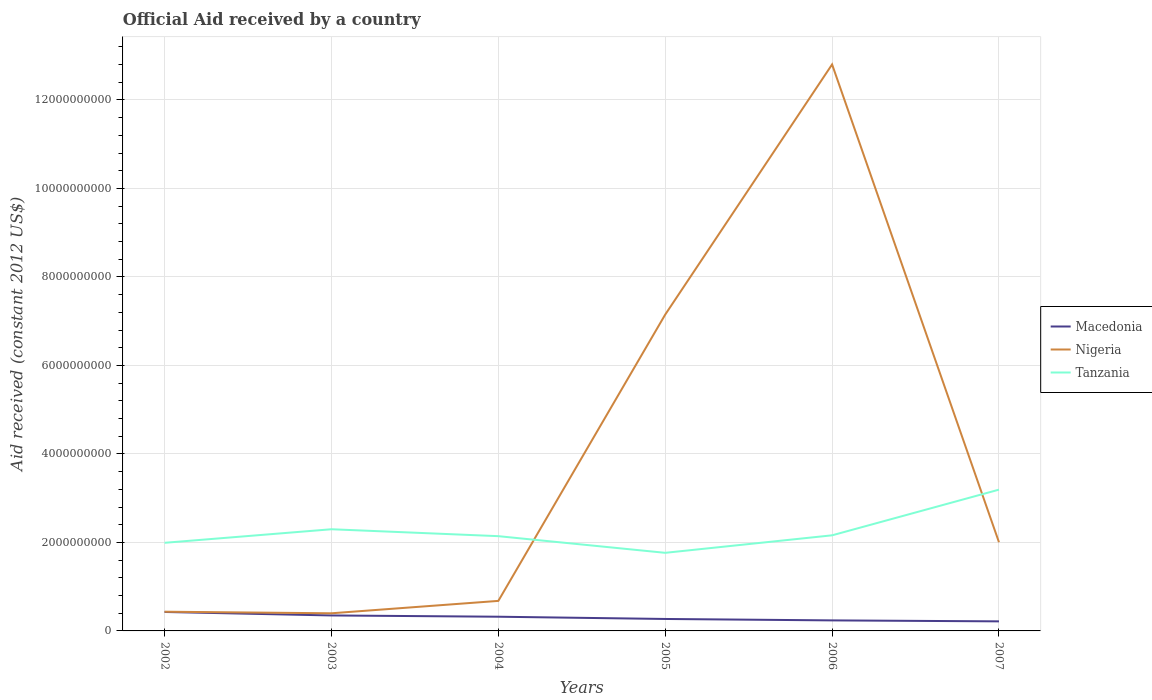How many different coloured lines are there?
Give a very brief answer. 3. Does the line corresponding to Nigeria intersect with the line corresponding to Tanzania?
Ensure brevity in your answer.  Yes. Is the number of lines equal to the number of legend labels?
Give a very brief answer. Yes. Across all years, what is the maximum net official aid received in Macedonia?
Your answer should be very brief. 2.16e+08. What is the total net official aid received in Tanzania in the graph?
Offer a terse response. 3.77e+08. What is the difference between the highest and the second highest net official aid received in Tanzania?
Keep it short and to the point. 1.43e+09. What is the difference between the highest and the lowest net official aid received in Nigeria?
Provide a short and direct response. 2. What is the title of the graph?
Keep it short and to the point. Official Aid received by a country. Does "Latin America(all income levels)" appear as one of the legend labels in the graph?
Keep it short and to the point. No. What is the label or title of the X-axis?
Your answer should be very brief. Years. What is the label or title of the Y-axis?
Give a very brief answer. Aid received (constant 2012 US$). What is the Aid received (constant 2012 US$) in Macedonia in 2002?
Your answer should be compact. 4.28e+08. What is the Aid received (constant 2012 US$) of Nigeria in 2002?
Your response must be concise. 4.34e+08. What is the Aid received (constant 2012 US$) in Tanzania in 2002?
Your answer should be very brief. 1.99e+09. What is the Aid received (constant 2012 US$) in Macedonia in 2003?
Offer a very short reply. 3.50e+08. What is the Aid received (constant 2012 US$) in Nigeria in 2003?
Your answer should be compact. 3.99e+08. What is the Aid received (constant 2012 US$) of Tanzania in 2003?
Give a very brief answer. 2.30e+09. What is the Aid received (constant 2012 US$) in Macedonia in 2004?
Your response must be concise. 3.21e+08. What is the Aid received (constant 2012 US$) of Nigeria in 2004?
Keep it short and to the point. 6.79e+08. What is the Aid received (constant 2012 US$) in Tanzania in 2004?
Give a very brief answer. 2.14e+09. What is the Aid received (constant 2012 US$) of Macedonia in 2005?
Your response must be concise. 2.70e+08. What is the Aid received (constant 2012 US$) in Nigeria in 2005?
Your response must be concise. 7.15e+09. What is the Aid received (constant 2012 US$) of Tanzania in 2005?
Offer a terse response. 1.77e+09. What is the Aid received (constant 2012 US$) in Macedonia in 2006?
Make the answer very short. 2.38e+08. What is the Aid received (constant 2012 US$) in Nigeria in 2006?
Your answer should be very brief. 1.28e+1. What is the Aid received (constant 2012 US$) in Tanzania in 2006?
Offer a terse response. 2.16e+09. What is the Aid received (constant 2012 US$) in Macedonia in 2007?
Provide a succinct answer. 2.16e+08. What is the Aid received (constant 2012 US$) of Nigeria in 2007?
Give a very brief answer. 2.00e+09. What is the Aid received (constant 2012 US$) of Tanzania in 2007?
Offer a very short reply. 3.19e+09. Across all years, what is the maximum Aid received (constant 2012 US$) in Macedonia?
Provide a short and direct response. 4.28e+08. Across all years, what is the maximum Aid received (constant 2012 US$) in Nigeria?
Your answer should be very brief. 1.28e+1. Across all years, what is the maximum Aid received (constant 2012 US$) of Tanzania?
Make the answer very short. 3.19e+09. Across all years, what is the minimum Aid received (constant 2012 US$) of Macedonia?
Make the answer very short. 2.16e+08. Across all years, what is the minimum Aid received (constant 2012 US$) in Nigeria?
Your response must be concise. 3.99e+08. Across all years, what is the minimum Aid received (constant 2012 US$) in Tanzania?
Your response must be concise. 1.77e+09. What is the total Aid received (constant 2012 US$) in Macedonia in the graph?
Your answer should be very brief. 1.82e+09. What is the total Aid received (constant 2012 US$) of Nigeria in the graph?
Your response must be concise. 2.35e+1. What is the total Aid received (constant 2012 US$) of Tanzania in the graph?
Offer a very short reply. 1.35e+1. What is the difference between the Aid received (constant 2012 US$) in Macedonia in 2002 and that in 2003?
Offer a very short reply. 7.88e+07. What is the difference between the Aid received (constant 2012 US$) in Nigeria in 2002 and that in 2003?
Make the answer very short. 3.58e+07. What is the difference between the Aid received (constant 2012 US$) of Tanzania in 2002 and that in 2003?
Your response must be concise. -3.06e+08. What is the difference between the Aid received (constant 2012 US$) of Macedonia in 2002 and that in 2004?
Your answer should be compact. 1.07e+08. What is the difference between the Aid received (constant 2012 US$) of Nigeria in 2002 and that in 2004?
Ensure brevity in your answer.  -2.44e+08. What is the difference between the Aid received (constant 2012 US$) of Tanzania in 2002 and that in 2004?
Make the answer very short. -1.50e+08. What is the difference between the Aid received (constant 2012 US$) in Macedonia in 2002 and that in 2005?
Give a very brief answer. 1.58e+08. What is the difference between the Aid received (constant 2012 US$) in Nigeria in 2002 and that in 2005?
Provide a succinct answer. -6.72e+09. What is the difference between the Aid received (constant 2012 US$) of Tanzania in 2002 and that in 2005?
Make the answer very short. 2.26e+08. What is the difference between the Aid received (constant 2012 US$) of Macedonia in 2002 and that in 2006?
Give a very brief answer. 1.90e+08. What is the difference between the Aid received (constant 2012 US$) of Nigeria in 2002 and that in 2006?
Your answer should be very brief. -1.24e+1. What is the difference between the Aid received (constant 2012 US$) in Tanzania in 2002 and that in 2006?
Offer a very short reply. -1.69e+08. What is the difference between the Aid received (constant 2012 US$) of Macedonia in 2002 and that in 2007?
Your answer should be compact. 2.12e+08. What is the difference between the Aid received (constant 2012 US$) in Nigeria in 2002 and that in 2007?
Offer a very short reply. -1.57e+09. What is the difference between the Aid received (constant 2012 US$) of Tanzania in 2002 and that in 2007?
Offer a terse response. -1.20e+09. What is the difference between the Aid received (constant 2012 US$) in Macedonia in 2003 and that in 2004?
Provide a succinct answer. 2.86e+07. What is the difference between the Aid received (constant 2012 US$) in Nigeria in 2003 and that in 2004?
Your response must be concise. -2.80e+08. What is the difference between the Aid received (constant 2012 US$) in Tanzania in 2003 and that in 2004?
Provide a succinct answer. 1.56e+08. What is the difference between the Aid received (constant 2012 US$) in Macedonia in 2003 and that in 2005?
Make the answer very short. 7.94e+07. What is the difference between the Aid received (constant 2012 US$) in Nigeria in 2003 and that in 2005?
Ensure brevity in your answer.  -6.75e+09. What is the difference between the Aid received (constant 2012 US$) of Tanzania in 2003 and that in 2005?
Ensure brevity in your answer.  5.33e+08. What is the difference between the Aid received (constant 2012 US$) of Macedonia in 2003 and that in 2006?
Give a very brief answer. 1.12e+08. What is the difference between the Aid received (constant 2012 US$) in Nigeria in 2003 and that in 2006?
Offer a terse response. -1.24e+1. What is the difference between the Aid received (constant 2012 US$) of Tanzania in 2003 and that in 2006?
Give a very brief answer. 1.37e+08. What is the difference between the Aid received (constant 2012 US$) of Macedonia in 2003 and that in 2007?
Provide a succinct answer. 1.34e+08. What is the difference between the Aid received (constant 2012 US$) of Nigeria in 2003 and that in 2007?
Provide a succinct answer. -1.61e+09. What is the difference between the Aid received (constant 2012 US$) of Tanzania in 2003 and that in 2007?
Keep it short and to the point. -8.95e+08. What is the difference between the Aid received (constant 2012 US$) in Macedonia in 2004 and that in 2005?
Provide a short and direct response. 5.08e+07. What is the difference between the Aid received (constant 2012 US$) of Nigeria in 2004 and that in 2005?
Give a very brief answer. -6.47e+09. What is the difference between the Aid received (constant 2012 US$) of Tanzania in 2004 and that in 2005?
Ensure brevity in your answer.  3.77e+08. What is the difference between the Aid received (constant 2012 US$) of Macedonia in 2004 and that in 2006?
Your answer should be very brief. 8.29e+07. What is the difference between the Aid received (constant 2012 US$) of Nigeria in 2004 and that in 2006?
Make the answer very short. -1.21e+1. What is the difference between the Aid received (constant 2012 US$) of Tanzania in 2004 and that in 2006?
Offer a terse response. -1.90e+07. What is the difference between the Aid received (constant 2012 US$) of Macedonia in 2004 and that in 2007?
Keep it short and to the point. 1.05e+08. What is the difference between the Aid received (constant 2012 US$) in Nigeria in 2004 and that in 2007?
Your answer should be very brief. -1.33e+09. What is the difference between the Aid received (constant 2012 US$) in Tanzania in 2004 and that in 2007?
Make the answer very short. -1.05e+09. What is the difference between the Aid received (constant 2012 US$) in Macedonia in 2005 and that in 2006?
Ensure brevity in your answer.  3.21e+07. What is the difference between the Aid received (constant 2012 US$) of Nigeria in 2005 and that in 2006?
Your response must be concise. -5.65e+09. What is the difference between the Aid received (constant 2012 US$) in Tanzania in 2005 and that in 2006?
Provide a short and direct response. -3.96e+08. What is the difference between the Aid received (constant 2012 US$) in Macedonia in 2005 and that in 2007?
Your answer should be compact. 5.42e+07. What is the difference between the Aid received (constant 2012 US$) in Nigeria in 2005 and that in 2007?
Provide a succinct answer. 5.15e+09. What is the difference between the Aid received (constant 2012 US$) in Tanzania in 2005 and that in 2007?
Offer a very short reply. -1.43e+09. What is the difference between the Aid received (constant 2012 US$) of Macedonia in 2006 and that in 2007?
Provide a succinct answer. 2.21e+07. What is the difference between the Aid received (constant 2012 US$) in Nigeria in 2006 and that in 2007?
Your response must be concise. 1.08e+1. What is the difference between the Aid received (constant 2012 US$) in Tanzania in 2006 and that in 2007?
Your response must be concise. -1.03e+09. What is the difference between the Aid received (constant 2012 US$) of Macedonia in 2002 and the Aid received (constant 2012 US$) of Nigeria in 2003?
Your response must be concise. 2.98e+07. What is the difference between the Aid received (constant 2012 US$) of Macedonia in 2002 and the Aid received (constant 2012 US$) of Tanzania in 2003?
Your answer should be very brief. -1.87e+09. What is the difference between the Aid received (constant 2012 US$) in Nigeria in 2002 and the Aid received (constant 2012 US$) in Tanzania in 2003?
Make the answer very short. -1.86e+09. What is the difference between the Aid received (constant 2012 US$) of Macedonia in 2002 and the Aid received (constant 2012 US$) of Nigeria in 2004?
Make the answer very short. -2.50e+08. What is the difference between the Aid received (constant 2012 US$) of Macedonia in 2002 and the Aid received (constant 2012 US$) of Tanzania in 2004?
Ensure brevity in your answer.  -1.71e+09. What is the difference between the Aid received (constant 2012 US$) of Nigeria in 2002 and the Aid received (constant 2012 US$) of Tanzania in 2004?
Your response must be concise. -1.71e+09. What is the difference between the Aid received (constant 2012 US$) in Macedonia in 2002 and the Aid received (constant 2012 US$) in Nigeria in 2005?
Offer a very short reply. -6.72e+09. What is the difference between the Aid received (constant 2012 US$) in Macedonia in 2002 and the Aid received (constant 2012 US$) in Tanzania in 2005?
Your response must be concise. -1.34e+09. What is the difference between the Aid received (constant 2012 US$) of Nigeria in 2002 and the Aid received (constant 2012 US$) of Tanzania in 2005?
Provide a short and direct response. -1.33e+09. What is the difference between the Aid received (constant 2012 US$) in Macedonia in 2002 and the Aid received (constant 2012 US$) in Nigeria in 2006?
Make the answer very short. -1.24e+1. What is the difference between the Aid received (constant 2012 US$) of Macedonia in 2002 and the Aid received (constant 2012 US$) of Tanzania in 2006?
Your response must be concise. -1.73e+09. What is the difference between the Aid received (constant 2012 US$) of Nigeria in 2002 and the Aid received (constant 2012 US$) of Tanzania in 2006?
Your answer should be very brief. -1.73e+09. What is the difference between the Aid received (constant 2012 US$) of Macedonia in 2002 and the Aid received (constant 2012 US$) of Nigeria in 2007?
Offer a very short reply. -1.58e+09. What is the difference between the Aid received (constant 2012 US$) in Macedonia in 2002 and the Aid received (constant 2012 US$) in Tanzania in 2007?
Keep it short and to the point. -2.76e+09. What is the difference between the Aid received (constant 2012 US$) of Nigeria in 2002 and the Aid received (constant 2012 US$) of Tanzania in 2007?
Your response must be concise. -2.76e+09. What is the difference between the Aid received (constant 2012 US$) of Macedonia in 2003 and the Aid received (constant 2012 US$) of Nigeria in 2004?
Provide a succinct answer. -3.29e+08. What is the difference between the Aid received (constant 2012 US$) in Macedonia in 2003 and the Aid received (constant 2012 US$) in Tanzania in 2004?
Provide a succinct answer. -1.79e+09. What is the difference between the Aid received (constant 2012 US$) of Nigeria in 2003 and the Aid received (constant 2012 US$) of Tanzania in 2004?
Make the answer very short. -1.74e+09. What is the difference between the Aid received (constant 2012 US$) of Macedonia in 2003 and the Aid received (constant 2012 US$) of Nigeria in 2005?
Your answer should be very brief. -6.80e+09. What is the difference between the Aid received (constant 2012 US$) in Macedonia in 2003 and the Aid received (constant 2012 US$) in Tanzania in 2005?
Provide a short and direct response. -1.42e+09. What is the difference between the Aid received (constant 2012 US$) in Nigeria in 2003 and the Aid received (constant 2012 US$) in Tanzania in 2005?
Your answer should be compact. -1.37e+09. What is the difference between the Aid received (constant 2012 US$) of Macedonia in 2003 and the Aid received (constant 2012 US$) of Nigeria in 2006?
Give a very brief answer. -1.25e+1. What is the difference between the Aid received (constant 2012 US$) in Macedonia in 2003 and the Aid received (constant 2012 US$) in Tanzania in 2006?
Your answer should be very brief. -1.81e+09. What is the difference between the Aid received (constant 2012 US$) in Nigeria in 2003 and the Aid received (constant 2012 US$) in Tanzania in 2006?
Give a very brief answer. -1.76e+09. What is the difference between the Aid received (constant 2012 US$) of Macedonia in 2003 and the Aid received (constant 2012 US$) of Nigeria in 2007?
Offer a very short reply. -1.65e+09. What is the difference between the Aid received (constant 2012 US$) in Macedonia in 2003 and the Aid received (constant 2012 US$) in Tanzania in 2007?
Keep it short and to the point. -2.84e+09. What is the difference between the Aid received (constant 2012 US$) in Nigeria in 2003 and the Aid received (constant 2012 US$) in Tanzania in 2007?
Make the answer very short. -2.79e+09. What is the difference between the Aid received (constant 2012 US$) of Macedonia in 2004 and the Aid received (constant 2012 US$) of Nigeria in 2005?
Your answer should be compact. -6.83e+09. What is the difference between the Aid received (constant 2012 US$) of Macedonia in 2004 and the Aid received (constant 2012 US$) of Tanzania in 2005?
Offer a very short reply. -1.44e+09. What is the difference between the Aid received (constant 2012 US$) in Nigeria in 2004 and the Aid received (constant 2012 US$) in Tanzania in 2005?
Provide a succinct answer. -1.09e+09. What is the difference between the Aid received (constant 2012 US$) in Macedonia in 2004 and the Aid received (constant 2012 US$) in Nigeria in 2006?
Make the answer very short. -1.25e+1. What is the difference between the Aid received (constant 2012 US$) in Macedonia in 2004 and the Aid received (constant 2012 US$) in Tanzania in 2006?
Offer a very short reply. -1.84e+09. What is the difference between the Aid received (constant 2012 US$) in Nigeria in 2004 and the Aid received (constant 2012 US$) in Tanzania in 2006?
Your answer should be very brief. -1.48e+09. What is the difference between the Aid received (constant 2012 US$) of Macedonia in 2004 and the Aid received (constant 2012 US$) of Nigeria in 2007?
Your answer should be very brief. -1.68e+09. What is the difference between the Aid received (constant 2012 US$) of Macedonia in 2004 and the Aid received (constant 2012 US$) of Tanzania in 2007?
Provide a succinct answer. -2.87e+09. What is the difference between the Aid received (constant 2012 US$) in Nigeria in 2004 and the Aid received (constant 2012 US$) in Tanzania in 2007?
Ensure brevity in your answer.  -2.51e+09. What is the difference between the Aid received (constant 2012 US$) in Macedonia in 2005 and the Aid received (constant 2012 US$) in Nigeria in 2006?
Your response must be concise. -1.25e+1. What is the difference between the Aid received (constant 2012 US$) of Macedonia in 2005 and the Aid received (constant 2012 US$) of Tanzania in 2006?
Your answer should be very brief. -1.89e+09. What is the difference between the Aid received (constant 2012 US$) of Nigeria in 2005 and the Aid received (constant 2012 US$) of Tanzania in 2006?
Provide a succinct answer. 4.99e+09. What is the difference between the Aid received (constant 2012 US$) in Macedonia in 2005 and the Aid received (constant 2012 US$) in Nigeria in 2007?
Your answer should be very brief. -1.73e+09. What is the difference between the Aid received (constant 2012 US$) of Macedonia in 2005 and the Aid received (constant 2012 US$) of Tanzania in 2007?
Offer a very short reply. -2.92e+09. What is the difference between the Aid received (constant 2012 US$) in Nigeria in 2005 and the Aid received (constant 2012 US$) in Tanzania in 2007?
Ensure brevity in your answer.  3.96e+09. What is the difference between the Aid received (constant 2012 US$) in Macedonia in 2006 and the Aid received (constant 2012 US$) in Nigeria in 2007?
Ensure brevity in your answer.  -1.77e+09. What is the difference between the Aid received (constant 2012 US$) in Macedonia in 2006 and the Aid received (constant 2012 US$) in Tanzania in 2007?
Keep it short and to the point. -2.95e+09. What is the difference between the Aid received (constant 2012 US$) in Nigeria in 2006 and the Aid received (constant 2012 US$) in Tanzania in 2007?
Keep it short and to the point. 9.61e+09. What is the average Aid received (constant 2012 US$) of Macedonia per year?
Ensure brevity in your answer.  3.04e+08. What is the average Aid received (constant 2012 US$) of Nigeria per year?
Provide a succinct answer. 3.91e+09. What is the average Aid received (constant 2012 US$) of Tanzania per year?
Your answer should be very brief. 2.26e+09. In the year 2002, what is the difference between the Aid received (constant 2012 US$) of Macedonia and Aid received (constant 2012 US$) of Nigeria?
Your response must be concise. -5.95e+06. In the year 2002, what is the difference between the Aid received (constant 2012 US$) of Macedonia and Aid received (constant 2012 US$) of Tanzania?
Your response must be concise. -1.56e+09. In the year 2002, what is the difference between the Aid received (constant 2012 US$) in Nigeria and Aid received (constant 2012 US$) in Tanzania?
Keep it short and to the point. -1.56e+09. In the year 2003, what is the difference between the Aid received (constant 2012 US$) in Macedonia and Aid received (constant 2012 US$) in Nigeria?
Your answer should be very brief. -4.90e+07. In the year 2003, what is the difference between the Aid received (constant 2012 US$) in Macedonia and Aid received (constant 2012 US$) in Tanzania?
Ensure brevity in your answer.  -1.95e+09. In the year 2003, what is the difference between the Aid received (constant 2012 US$) of Nigeria and Aid received (constant 2012 US$) of Tanzania?
Your answer should be very brief. -1.90e+09. In the year 2004, what is the difference between the Aid received (constant 2012 US$) of Macedonia and Aid received (constant 2012 US$) of Nigeria?
Give a very brief answer. -3.58e+08. In the year 2004, what is the difference between the Aid received (constant 2012 US$) in Macedonia and Aid received (constant 2012 US$) in Tanzania?
Make the answer very short. -1.82e+09. In the year 2004, what is the difference between the Aid received (constant 2012 US$) of Nigeria and Aid received (constant 2012 US$) of Tanzania?
Offer a terse response. -1.46e+09. In the year 2005, what is the difference between the Aid received (constant 2012 US$) in Macedonia and Aid received (constant 2012 US$) in Nigeria?
Your response must be concise. -6.88e+09. In the year 2005, what is the difference between the Aid received (constant 2012 US$) in Macedonia and Aid received (constant 2012 US$) in Tanzania?
Offer a terse response. -1.49e+09. In the year 2005, what is the difference between the Aid received (constant 2012 US$) of Nigeria and Aid received (constant 2012 US$) of Tanzania?
Offer a very short reply. 5.38e+09. In the year 2006, what is the difference between the Aid received (constant 2012 US$) of Macedonia and Aid received (constant 2012 US$) of Nigeria?
Ensure brevity in your answer.  -1.26e+1. In the year 2006, what is the difference between the Aid received (constant 2012 US$) in Macedonia and Aid received (constant 2012 US$) in Tanzania?
Offer a terse response. -1.92e+09. In the year 2006, what is the difference between the Aid received (constant 2012 US$) of Nigeria and Aid received (constant 2012 US$) of Tanzania?
Your response must be concise. 1.06e+1. In the year 2007, what is the difference between the Aid received (constant 2012 US$) in Macedonia and Aid received (constant 2012 US$) in Nigeria?
Offer a terse response. -1.79e+09. In the year 2007, what is the difference between the Aid received (constant 2012 US$) in Macedonia and Aid received (constant 2012 US$) in Tanzania?
Provide a succinct answer. -2.98e+09. In the year 2007, what is the difference between the Aid received (constant 2012 US$) of Nigeria and Aid received (constant 2012 US$) of Tanzania?
Make the answer very short. -1.19e+09. What is the ratio of the Aid received (constant 2012 US$) in Macedonia in 2002 to that in 2003?
Your answer should be very brief. 1.23. What is the ratio of the Aid received (constant 2012 US$) of Nigeria in 2002 to that in 2003?
Provide a short and direct response. 1.09. What is the ratio of the Aid received (constant 2012 US$) of Tanzania in 2002 to that in 2003?
Offer a very short reply. 0.87. What is the ratio of the Aid received (constant 2012 US$) in Macedonia in 2002 to that in 2004?
Give a very brief answer. 1.33. What is the ratio of the Aid received (constant 2012 US$) of Nigeria in 2002 to that in 2004?
Give a very brief answer. 0.64. What is the ratio of the Aid received (constant 2012 US$) in Tanzania in 2002 to that in 2004?
Provide a succinct answer. 0.93. What is the ratio of the Aid received (constant 2012 US$) in Macedonia in 2002 to that in 2005?
Offer a very short reply. 1.59. What is the ratio of the Aid received (constant 2012 US$) of Nigeria in 2002 to that in 2005?
Offer a terse response. 0.06. What is the ratio of the Aid received (constant 2012 US$) of Tanzania in 2002 to that in 2005?
Your answer should be very brief. 1.13. What is the ratio of the Aid received (constant 2012 US$) in Macedonia in 2002 to that in 2006?
Keep it short and to the point. 1.8. What is the ratio of the Aid received (constant 2012 US$) of Nigeria in 2002 to that in 2006?
Offer a terse response. 0.03. What is the ratio of the Aid received (constant 2012 US$) of Tanzania in 2002 to that in 2006?
Your response must be concise. 0.92. What is the ratio of the Aid received (constant 2012 US$) of Macedonia in 2002 to that in 2007?
Keep it short and to the point. 1.98. What is the ratio of the Aid received (constant 2012 US$) of Nigeria in 2002 to that in 2007?
Give a very brief answer. 0.22. What is the ratio of the Aid received (constant 2012 US$) in Tanzania in 2002 to that in 2007?
Keep it short and to the point. 0.62. What is the ratio of the Aid received (constant 2012 US$) in Macedonia in 2003 to that in 2004?
Offer a very short reply. 1.09. What is the ratio of the Aid received (constant 2012 US$) of Nigeria in 2003 to that in 2004?
Your answer should be compact. 0.59. What is the ratio of the Aid received (constant 2012 US$) in Tanzania in 2003 to that in 2004?
Ensure brevity in your answer.  1.07. What is the ratio of the Aid received (constant 2012 US$) of Macedonia in 2003 to that in 2005?
Keep it short and to the point. 1.29. What is the ratio of the Aid received (constant 2012 US$) of Nigeria in 2003 to that in 2005?
Your answer should be very brief. 0.06. What is the ratio of the Aid received (constant 2012 US$) of Tanzania in 2003 to that in 2005?
Your answer should be very brief. 1.3. What is the ratio of the Aid received (constant 2012 US$) of Macedonia in 2003 to that in 2006?
Provide a short and direct response. 1.47. What is the ratio of the Aid received (constant 2012 US$) of Nigeria in 2003 to that in 2006?
Give a very brief answer. 0.03. What is the ratio of the Aid received (constant 2012 US$) of Tanzania in 2003 to that in 2006?
Provide a succinct answer. 1.06. What is the ratio of the Aid received (constant 2012 US$) in Macedonia in 2003 to that in 2007?
Give a very brief answer. 1.62. What is the ratio of the Aid received (constant 2012 US$) in Nigeria in 2003 to that in 2007?
Provide a short and direct response. 0.2. What is the ratio of the Aid received (constant 2012 US$) in Tanzania in 2003 to that in 2007?
Ensure brevity in your answer.  0.72. What is the ratio of the Aid received (constant 2012 US$) of Macedonia in 2004 to that in 2005?
Provide a short and direct response. 1.19. What is the ratio of the Aid received (constant 2012 US$) of Nigeria in 2004 to that in 2005?
Your answer should be compact. 0.09. What is the ratio of the Aid received (constant 2012 US$) of Tanzania in 2004 to that in 2005?
Provide a short and direct response. 1.21. What is the ratio of the Aid received (constant 2012 US$) in Macedonia in 2004 to that in 2006?
Ensure brevity in your answer.  1.35. What is the ratio of the Aid received (constant 2012 US$) of Nigeria in 2004 to that in 2006?
Offer a terse response. 0.05. What is the ratio of the Aid received (constant 2012 US$) of Tanzania in 2004 to that in 2006?
Your answer should be very brief. 0.99. What is the ratio of the Aid received (constant 2012 US$) of Macedonia in 2004 to that in 2007?
Offer a very short reply. 1.49. What is the ratio of the Aid received (constant 2012 US$) of Nigeria in 2004 to that in 2007?
Provide a succinct answer. 0.34. What is the ratio of the Aid received (constant 2012 US$) in Tanzania in 2004 to that in 2007?
Ensure brevity in your answer.  0.67. What is the ratio of the Aid received (constant 2012 US$) of Macedonia in 2005 to that in 2006?
Make the answer very short. 1.13. What is the ratio of the Aid received (constant 2012 US$) of Nigeria in 2005 to that in 2006?
Offer a very short reply. 0.56. What is the ratio of the Aid received (constant 2012 US$) of Tanzania in 2005 to that in 2006?
Provide a short and direct response. 0.82. What is the ratio of the Aid received (constant 2012 US$) of Macedonia in 2005 to that in 2007?
Your answer should be compact. 1.25. What is the ratio of the Aid received (constant 2012 US$) of Nigeria in 2005 to that in 2007?
Give a very brief answer. 3.57. What is the ratio of the Aid received (constant 2012 US$) of Tanzania in 2005 to that in 2007?
Make the answer very short. 0.55. What is the ratio of the Aid received (constant 2012 US$) of Macedonia in 2006 to that in 2007?
Make the answer very short. 1.1. What is the ratio of the Aid received (constant 2012 US$) of Nigeria in 2006 to that in 2007?
Your response must be concise. 6.39. What is the ratio of the Aid received (constant 2012 US$) in Tanzania in 2006 to that in 2007?
Provide a short and direct response. 0.68. What is the difference between the highest and the second highest Aid received (constant 2012 US$) of Macedonia?
Your response must be concise. 7.88e+07. What is the difference between the highest and the second highest Aid received (constant 2012 US$) of Nigeria?
Ensure brevity in your answer.  5.65e+09. What is the difference between the highest and the second highest Aid received (constant 2012 US$) in Tanzania?
Provide a succinct answer. 8.95e+08. What is the difference between the highest and the lowest Aid received (constant 2012 US$) in Macedonia?
Your answer should be very brief. 2.12e+08. What is the difference between the highest and the lowest Aid received (constant 2012 US$) of Nigeria?
Give a very brief answer. 1.24e+1. What is the difference between the highest and the lowest Aid received (constant 2012 US$) of Tanzania?
Provide a short and direct response. 1.43e+09. 